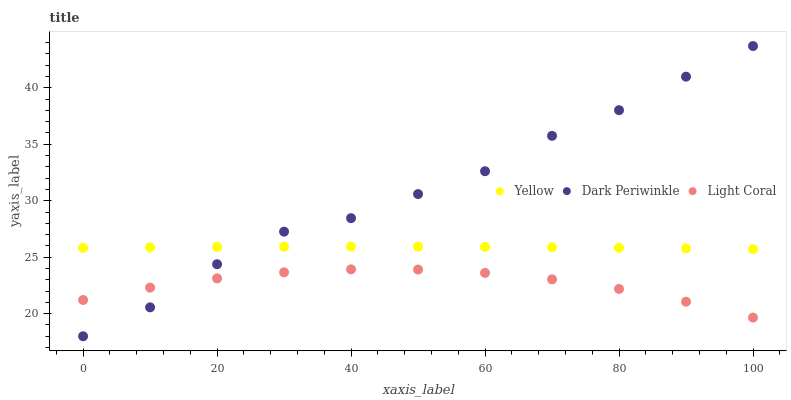Does Light Coral have the minimum area under the curve?
Answer yes or no. Yes. Does Dark Periwinkle have the maximum area under the curve?
Answer yes or no. Yes. Does Yellow have the minimum area under the curve?
Answer yes or no. No. Does Yellow have the maximum area under the curve?
Answer yes or no. No. Is Yellow the smoothest?
Answer yes or no. Yes. Is Dark Periwinkle the roughest?
Answer yes or no. Yes. Is Dark Periwinkle the smoothest?
Answer yes or no. No. Is Yellow the roughest?
Answer yes or no. No. Does Dark Periwinkle have the lowest value?
Answer yes or no. Yes. Does Yellow have the lowest value?
Answer yes or no. No. Does Dark Periwinkle have the highest value?
Answer yes or no. Yes. Does Yellow have the highest value?
Answer yes or no. No. Is Light Coral less than Yellow?
Answer yes or no. Yes. Is Yellow greater than Light Coral?
Answer yes or no. Yes. Does Light Coral intersect Dark Periwinkle?
Answer yes or no. Yes. Is Light Coral less than Dark Periwinkle?
Answer yes or no. No. Is Light Coral greater than Dark Periwinkle?
Answer yes or no. No. Does Light Coral intersect Yellow?
Answer yes or no. No. 